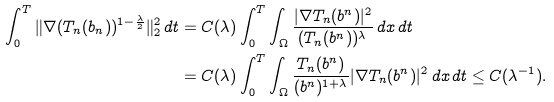Convert formula to latex. <formula><loc_0><loc_0><loc_500><loc_500>\int _ { 0 } ^ { T } \| \nabla ( T _ { n } ( b _ { n } ) ) ^ { 1 - \frac { \lambda } { 2 } } \| _ { 2 } ^ { 2 } \, d t & = C ( \lambda ) \int _ { 0 } ^ { T } \int _ { \Omega } \frac { | \nabla T _ { n } ( b ^ { n } ) | ^ { 2 } } { ( T _ { n } ( b ^ { n } ) ) ^ { \lambda } } \, d x \, d t \\ & = C ( \lambda ) \int _ { 0 } ^ { T } \int _ { \Omega } \frac { T _ { n } ( b ^ { n } ) } { ( b ^ { n } ) ^ { 1 + \lambda } } | \nabla T _ { n } ( b ^ { n } ) | ^ { 2 } \, d x \, d t \leq C ( \lambda ^ { - 1 } ) .</formula> 